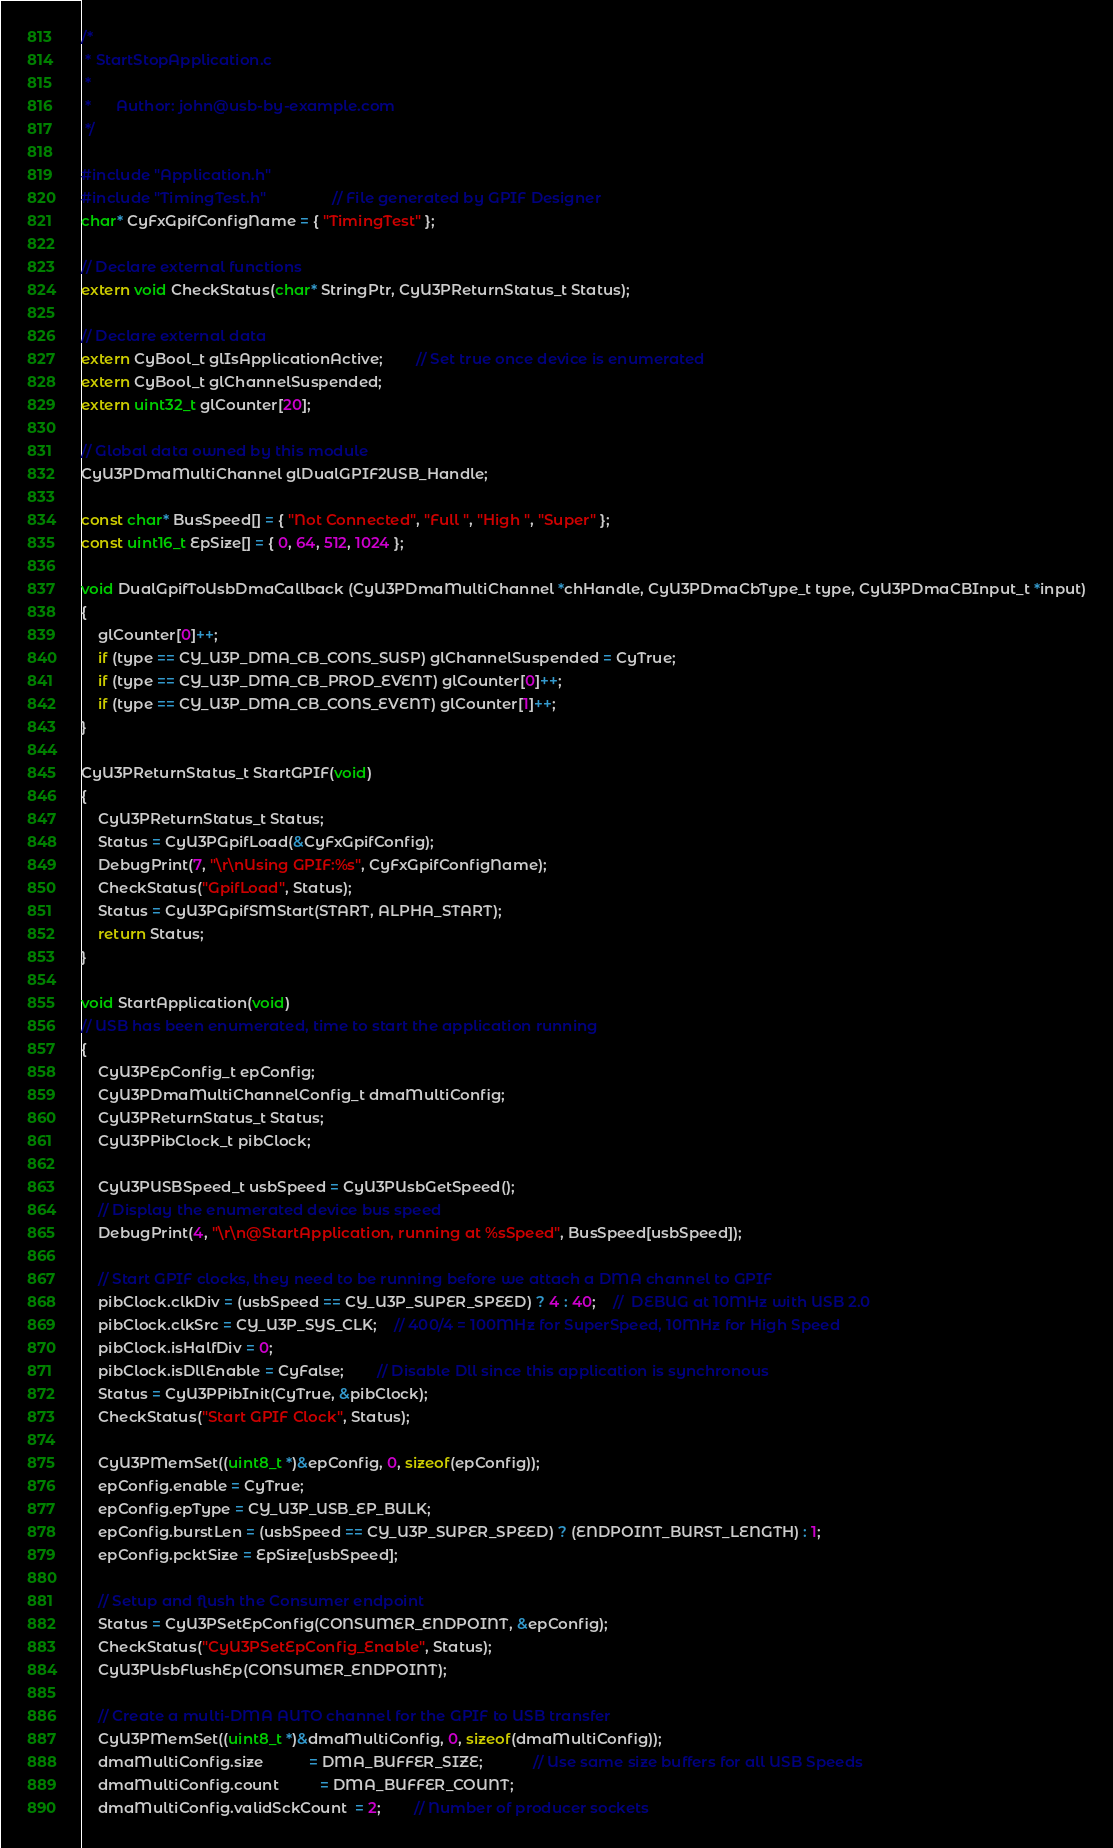<code> <loc_0><loc_0><loc_500><loc_500><_C_>/*
 * StartStopApplication.c
 *
 *      Author: john@usb-by-example.com
 */

#include "Application.h"
#include "TimingTest.h"				// File generated by GPIF Designer
char* CyFxGpifConfigName = { "TimingTest" };

// Declare external functions
extern void CheckStatus(char* StringPtr, CyU3PReturnStatus_t Status);

// Declare external data
extern CyBool_t glIsApplicationActive;		// Set true once device is enumerated
extern CyBool_t glChannelSuspended;
extern uint32_t glCounter[20];

// Global data owned by this module
CyU3PDmaMultiChannel glDualGPIF2USB_Handle;

const char* BusSpeed[] = { "Not Connected", "Full ", "High ", "Super" };
const uint16_t EpSize[] = { 0, 64, 512, 1024 };

void DualGpifToUsbDmaCallback (CyU3PDmaMultiChannel *chHandle, CyU3PDmaCbType_t type, CyU3PDmaCBInput_t *input)
{
	glCounter[0]++;
    if (type == CY_U3P_DMA_CB_CONS_SUSP) glChannelSuspended = CyTrue;
    if (type == CY_U3P_DMA_CB_PROD_EVENT) glCounter[0]++;
    if (type == CY_U3P_DMA_CB_CONS_EVENT) glCounter[1]++;
}

CyU3PReturnStatus_t StartGPIF(void)
{
	CyU3PReturnStatus_t Status;
	Status = CyU3PGpifLoad(&CyFxGpifConfig);
	DebugPrint(7, "\r\nUsing GPIF:%s", CyFxGpifConfigName);
	CheckStatus("GpifLoad", Status);
	Status = CyU3PGpifSMStart(START, ALPHA_START);
	return Status;
}

void StartApplication(void)
// USB has been enumerated, time to start the application running
{
	CyU3PEpConfig_t epConfig;
    CyU3PDmaMultiChannelConfig_t dmaMultiConfig;
	CyU3PReturnStatus_t Status;
    CyU3PPibClock_t pibClock;

    CyU3PUSBSpeed_t usbSpeed = CyU3PUsbGetSpeed();
    // Display the enumerated device bus speed
    DebugPrint(4, "\r\n@StartApplication, running at %sSpeed", BusSpeed[usbSpeed]);

	// Start GPIF clocks, they need to be running before we attach a DMA channel to GPIF
    pibClock.clkDiv = (usbSpeed == CY_U3P_SUPER_SPEED) ? 4 : 40;	//	DEBUG at 10MHz with USB 2.0
    pibClock.clkSrc = CY_U3P_SYS_CLK;	// 400/4 = 100MHz for SuperSpeed, 10MHz for High Speed
    pibClock.isHalfDiv = 0;
    pibClock.isDllEnable = CyFalse;		// Disable Dll since this application is synchronous
    Status = CyU3PPibInit(CyTrue, &pibClock);
    CheckStatus("Start GPIF Clock", Status);

	CyU3PMemSet((uint8_t *)&epConfig, 0, sizeof(epConfig));
	epConfig.enable = CyTrue;
	epConfig.epType = CY_U3P_USB_EP_BULK;
	epConfig.burstLen = (usbSpeed == CY_U3P_SUPER_SPEED) ? (ENDPOINT_BURST_LENGTH) : 1;
	epConfig.pcktSize = EpSize[usbSpeed];

	// Setup and flush the Consumer endpoint
	Status = CyU3PSetEpConfig(CONSUMER_ENDPOINT, &epConfig);
	CheckStatus("CyU3PSetEpConfig_Enable", Status);
	CyU3PUsbFlushEp(CONSUMER_ENDPOINT);

	// Create a multi-DMA AUTO channel for the GPIF to USB transfer
	CyU3PMemSet((uint8_t *)&dmaMultiConfig, 0, sizeof(dmaMultiConfig));
	dmaMultiConfig.size           = DMA_BUFFER_SIZE;			// Use same size buffers for all USB Speeds
	dmaMultiConfig.count          = DMA_BUFFER_COUNT;
	dmaMultiConfig.validSckCount  = 2;		// Number of producer sockets</code> 